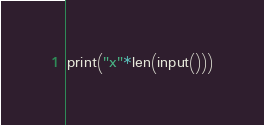Convert code to text. <code><loc_0><loc_0><loc_500><loc_500><_Python_>print("x"*len(input()))</code> 